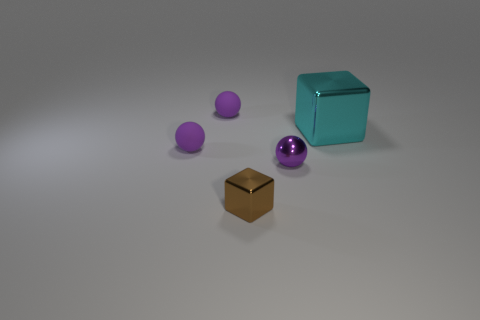Is there any other thing that has the same size as the cyan metallic thing?
Offer a very short reply. No. What color is the tiny metallic thing in front of the metal ball?
Keep it short and to the point. Brown. What material is the object that is behind the block that is behind the purple metal object?
Give a very brief answer. Rubber. Is there another metal object that has the same size as the brown object?
Offer a very short reply. Yes. How many things are tiny purple matte balls that are behind the big thing or objects to the right of the tiny metal cube?
Ensure brevity in your answer.  3. There is a object on the right side of the purple shiny thing; is it the same size as the shiny block in front of the tiny purple shiny object?
Offer a terse response. No. There is a purple matte object that is behind the cyan thing; are there any spheres in front of it?
Give a very brief answer. Yes. What number of brown things are behind the large thing?
Give a very brief answer. 0. What number of other things are the same color as the small cube?
Offer a very short reply. 0. Are there fewer purple shiny things that are in front of the tiny brown object than rubber spheres that are behind the big cyan shiny thing?
Your response must be concise. Yes. 